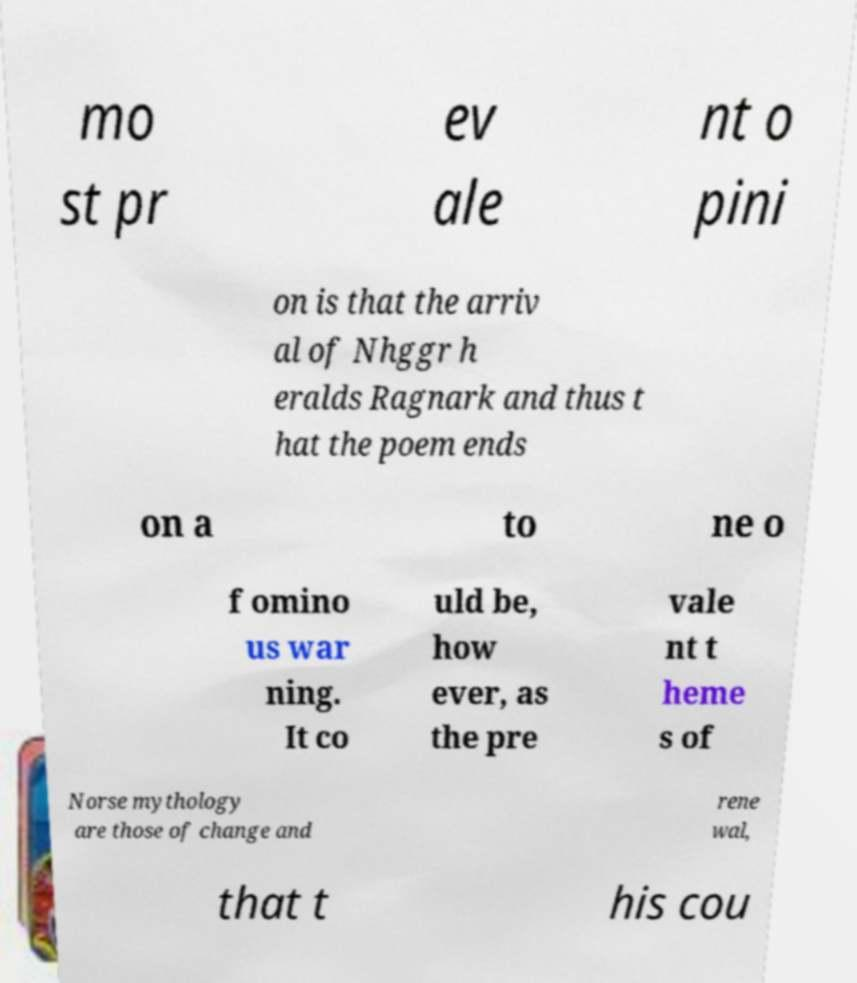Can you accurately transcribe the text from the provided image for me? mo st pr ev ale nt o pini on is that the arriv al of Nhggr h eralds Ragnark and thus t hat the poem ends on a to ne o f omino us war ning. It co uld be, how ever, as the pre vale nt t heme s of Norse mythology are those of change and rene wal, that t his cou 